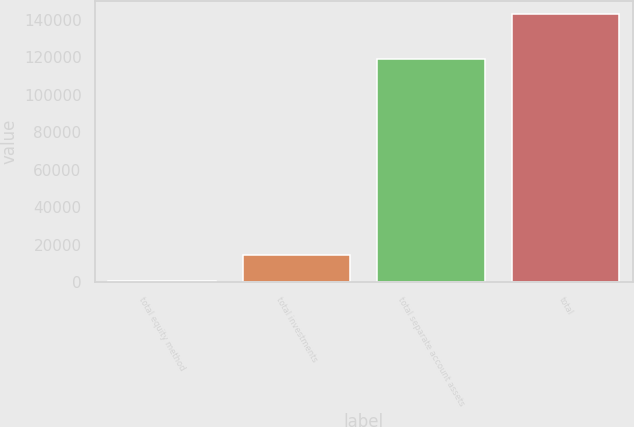<chart> <loc_0><loc_0><loc_500><loc_500><bar_chart><fcel>total equity method<fcel>total investments<fcel>total separate account assets<fcel>total<nl><fcel>457<fcel>14718.3<fcel>118871<fcel>143070<nl></chart> 